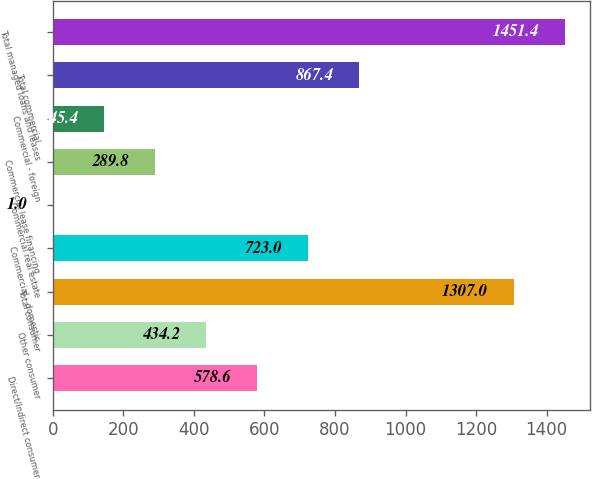Convert chart. <chart><loc_0><loc_0><loc_500><loc_500><bar_chart><fcel>Direct/Indirect consumer<fcel>Other consumer<fcel>Total consumer<fcel>Commercial - domestic<fcel>Commercial real estate<fcel>Commercial lease financing<fcel>Commercial - foreign<fcel>Total commercial<fcel>Total managed loans and leases<nl><fcel>578.6<fcel>434.2<fcel>1307<fcel>723<fcel>1<fcel>289.8<fcel>145.4<fcel>867.4<fcel>1451.4<nl></chart> 